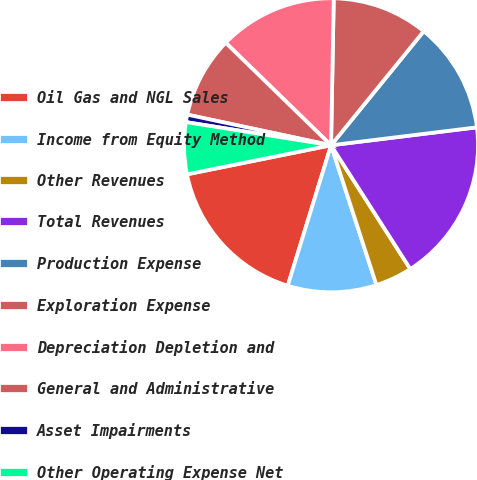<chart> <loc_0><loc_0><loc_500><loc_500><pie_chart><fcel>Oil Gas and NGL Sales<fcel>Income from Equity Method<fcel>Other Revenues<fcel>Total Revenues<fcel>Production Expense<fcel>Exploration Expense<fcel>Depreciation Depletion and<fcel>General and Administrative<fcel>Asset Impairments<fcel>Other Operating Expense Net<nl><fcel>17.07%<fcel>9.76%<fcel>4.07%<fcel>17.88%<fcel>12.19%<fcel>10.57%<fcel>13.01%<fcel>8.94%<fcel>0.82%<fcel>5.69%<nl></chart> 